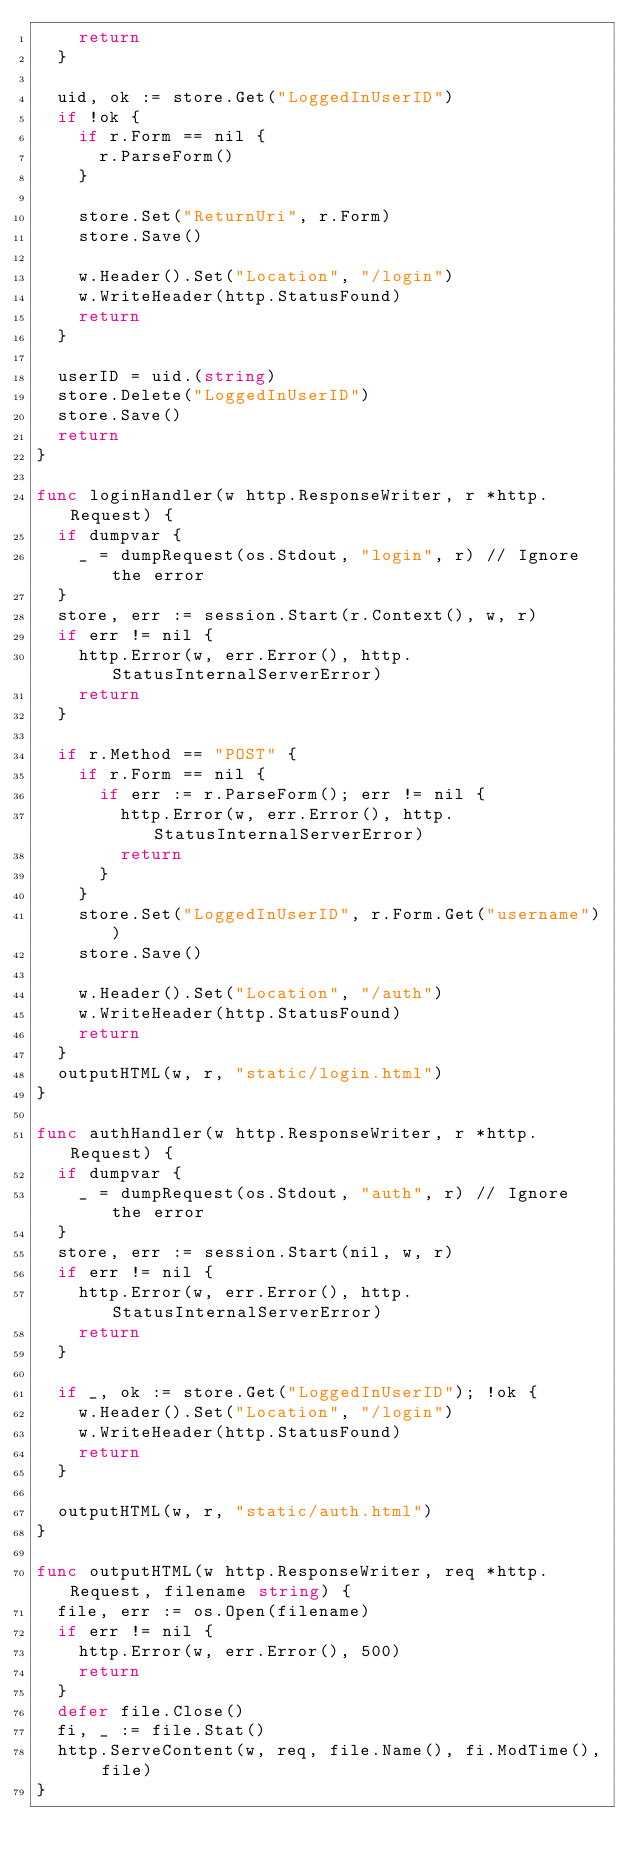Convert code to text. <code><loc_0><loc_0><loc_500><loc_500><_Go_>		return
	}

	uid, ok := store.Get("LoggedInUserID")
	if !ok {
		if r.Form == nil {
			r.ParseForm()
		}

		store.Set("ReturnUri", r.Form)
		store.Save()

		w.Header().Set("Location", "/login")
		w.WriteHeader(http.StatusFound)
		return
	}

	userID = uid.(string)
	store.Delete("LoggedInUserID")
	store.Save()
	return
}

func loginHandler(w http.ResponseWriter, r *http.Request) {
	if dumpvar {
		_ = dumpRequest(os.Stdout, "login", r) // Ignore the error
	}
	store, err := session.Start(r.Context(), w, r)
	if err != nil {
		http.Error(w, err.Error(), http.StatusInternalServerError)
		return
	}

	if r.Method == "POST" {
		if r.Form == nil {
			if err := r.ParseForm(); err != nil {
				http.Error(w, err.Error(), http.StatusInternalServerError)
				return
			}
		}
		store.Set("LoggedInUserID", r.Form.Get("username"))
		store.Save()

		w.Header().Set("Location", "/auth")
		w.WriteHeader(http.StatusFound)
		return
	}
	outputHTML(w, r, "static/login.html")
}

func authHandler(w http.ResponseWriter, r *http.Request) {
	if dumpvar {
		_ = dumpRequest(os.Stdout, "auth", r) // Ignore the error
	}
	store, err := session.Start(nil, w, r)
	if err != nil {
		http.Error(w, err.Error(), http.StatusInternalServerError)
		return
	}

	if _, ok := store.Get("LoggedInUserID"); !ok {
		w.Header().Set("Location", "/login")
		w.WriteHeader(http.StatusFound)
		return
	}

	outputHTML(w, r, "static/auth.html")
}

func outputHTML(w http.ResponseWriter, req *http.Request, filename string) {
	file, err := os.Open(filename)
	if err != nil {
		http.Error(w, err.Error(), 500)
		return
	}
	defer file.Close()
	fi, _ := file.Stat()
	http.ServeContent(w, req, file.Name(), fi.ModTime(), file)
}
</code> 